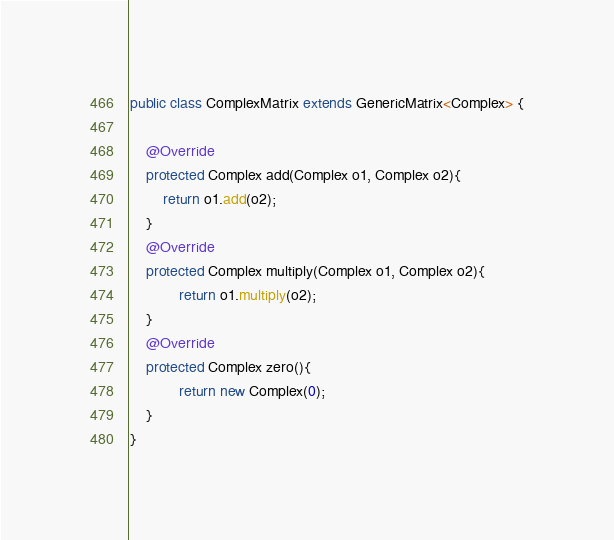<code> <loc_0><loc_0><loc_500><loc_500><_Java_>public class ComplexMatrix extends GenericMatrix<Complex> {
	
	@Override
	protected Complex add(Complex o1, Complex o2){
		return o1.add(o2);
	}
	@Override
	protected Complex multiply(Complex o1, Complex o2){
			return o1.multiply(o2);
	}
	@Override
	protected Complex zero(){
			return new Complex(0);
	}
}</code> 